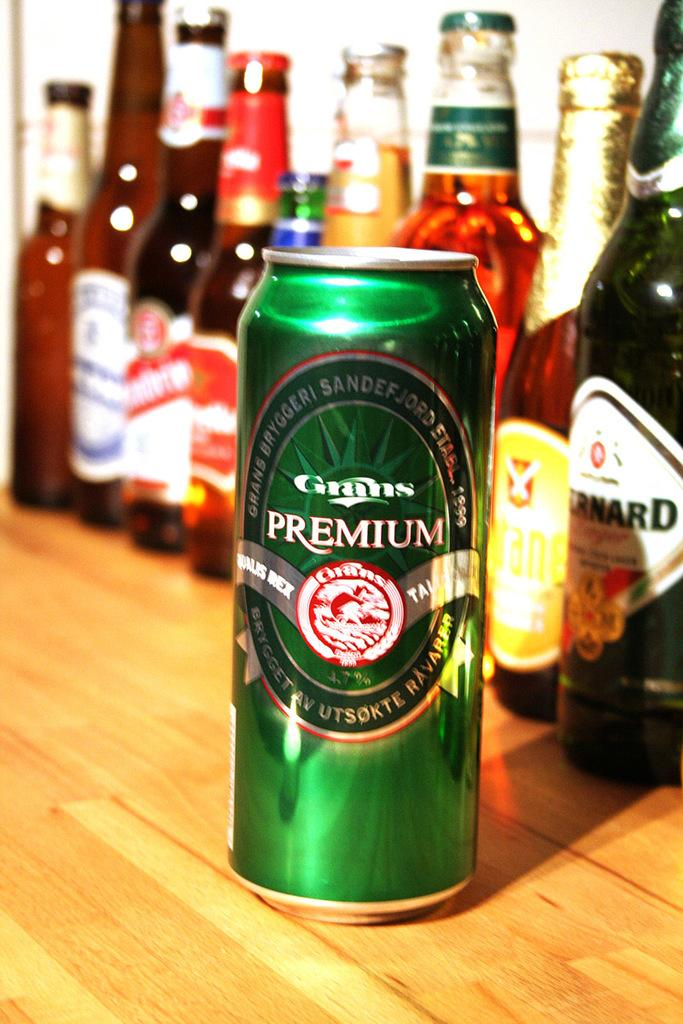<image>
Render a clear and concise summary of the photo. Green can of Grans Premium beer in front of some bottles of beer. 